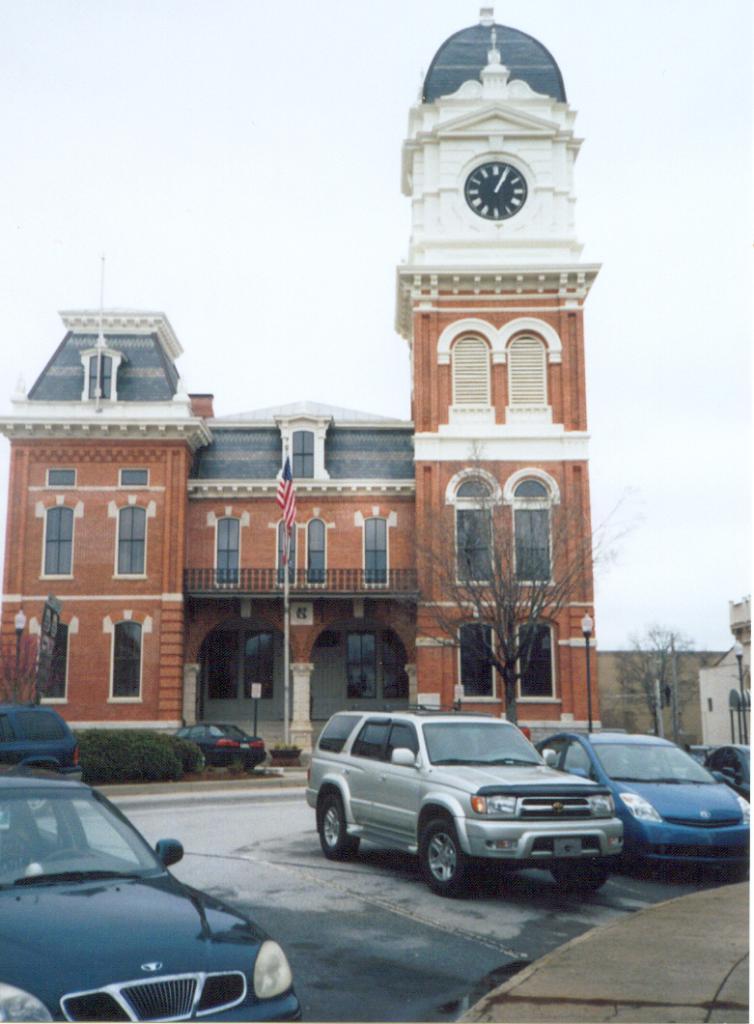Could you give a brief overview of what you see in this image? There are vehicles in the foreground area of the image, there are lamp poles, trees, buildings and the sky in the background. 